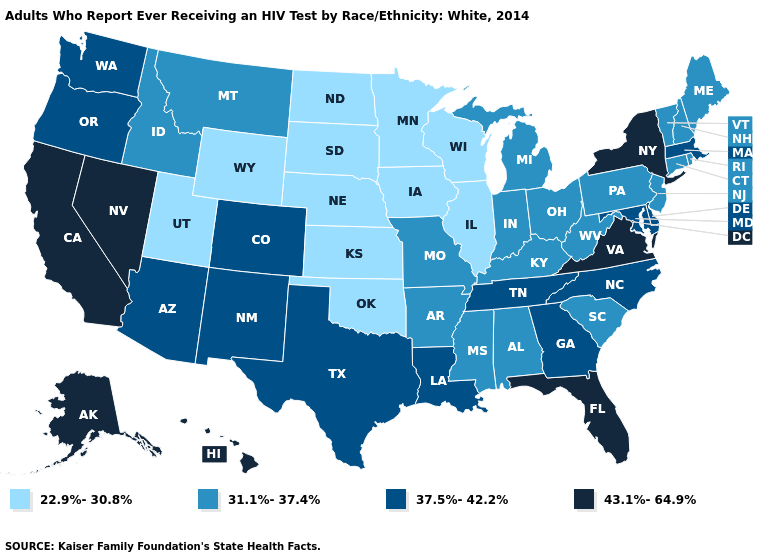What is the value of Missouri?
Short answer required. 31.1%-37.4%. Name the states that have a value in the range 37.5%-42.2%?
Short answer required. Arizona, Colorado, Delaware, Georgia, Louisiana, Maryland, Massachusetts, New Mexico, North Carolina, Oregon, Tennessee, Texas, Washington. Name the states that have a value in the range 37.5%-42.2%?
Write a very short answer. Arizona, Colorado, Delaware, Georgia, Louisiana, Maryland, Massachusetts, New Mexico, North Carolina, Oregon, Tennessee, Texas, Washington. Name the states that have a value in the range 22.9%-30.8%?
Be succinct. Illinois, Iowa, Kansas, Minnesota, Nebraska, North Dakota, Oklahoma, South Dakota, Utah, Wisconsin, Wyoming. Which states hav the highest value in the South?
Quick response, please. Florida, Virginia. What is the highest value in the West ?
Answer briefly. 43.1%-64.9%. What is the value of Wyoming?
Write a very short answer. 22.9%-30.8%. What is the value of Nevada?
Short answer required. 43.1%-64.9%. Does Colorado have a higher value than Wyoming?
Answer briefly. Yes. What is the highest value in states that border Idaho?
Be succinct. 43.1%-64.9%. Which states hav the highest value in the MidWest?
Give a very brief answer. Indiana, Michigan, Missouri, Ohio. Among the states that border California , which have the highest value?
Answer briefly. Nevada. Name the states that have a value in the range 37.5%-42.2%?
Write a very short answer. Arizona, Colorado, Delaware, Georgia, Louisiana, Maryland, Massachusetts, New Mexico, North Carolina, Oregon, Tennessee, Texas, Washington. Does the first symbol in the legend represent the smallest category?
Be succinct. Yes. Which states have the highest value in the USA?
Give a very brief answer. Alaska, California, Florida, Hawaii, Nevada, New York, Virginia. 